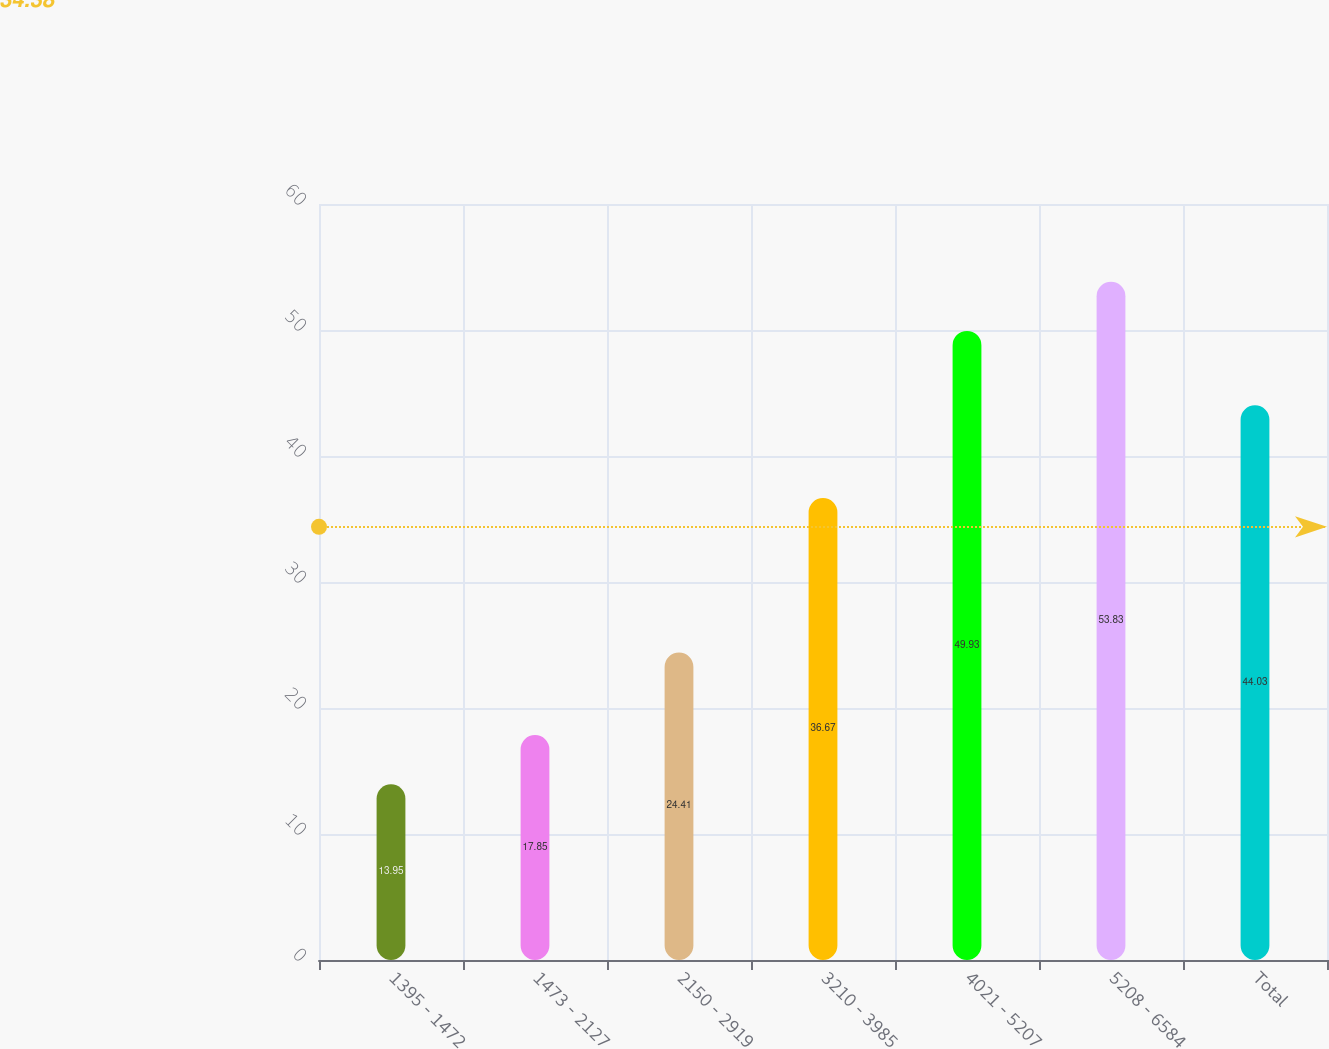<chart> <loc_0><loc_0><loc_500><loc_500><bar_chart><fcel>1395 - 1472<fcel>1473 - 2127<fcel>2150 - 2919<fcel>3210 - 3985<fcel>4021 - 5207<fcel>5208 - 6584<fcel>Total<nl><fcel>13.95<fcel>17.85<fcel>24.41<fcel>36.67<fcel>49.93<fcel>53.83<fcel>44.03<nl></chart> 